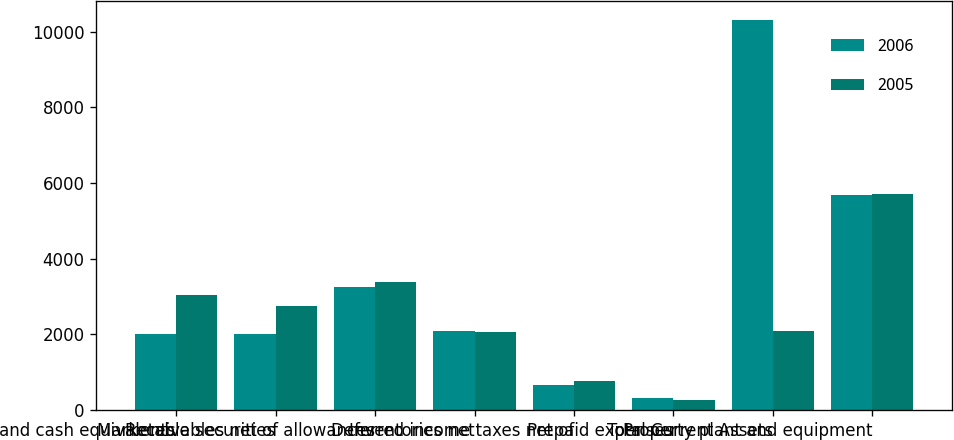<chart> <loc_0><loc_0><loc_500><loc_500><stacked_bar_chart><ecel><fcel>Cash and cash equivalents<fcel>Marketable securities<fcel>Receivables net of allowances<fcel>Inventories net<fcel>Deferred income taxes net of<fcel>Prepaid expenses<fcel>Total Current Assets<fcel>Property plant and equipment<nl><fcel>2006<fcel>2018<fcel>1995<fcel>3247<fcel>2079<fcel>649<fcel>314<fcel>10302<fcel>5673<nl><fcel>2005<fcel>3050<fcel>2749<fcel>3378<fcel>2060<fcel>776<fcel>270<fcel>2079<fcel>5693<nl></chart> 